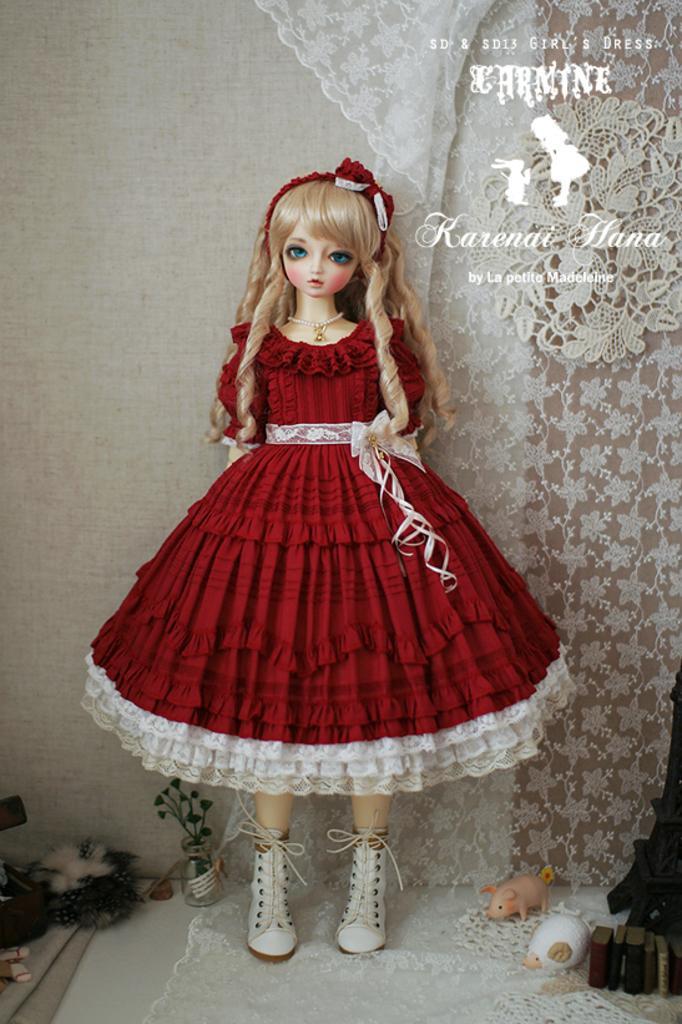Can you describe this image briefly? We can see doll standing on a cloth,toys,books,plant in a glass vase and some objects on the surface,behind this doll we can see wall and white cloth and we can see some text. 